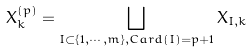Convert formula to latex. <formula><loc_0><loc_0><loc_500><loc_500>X ^ { ( p ) } _ { k } = \bigsqcup _ { I \subset \{ 1 , \cdots , m \} , C a r d ( I ) = p + 1 } X _ { I , k }</formula> 